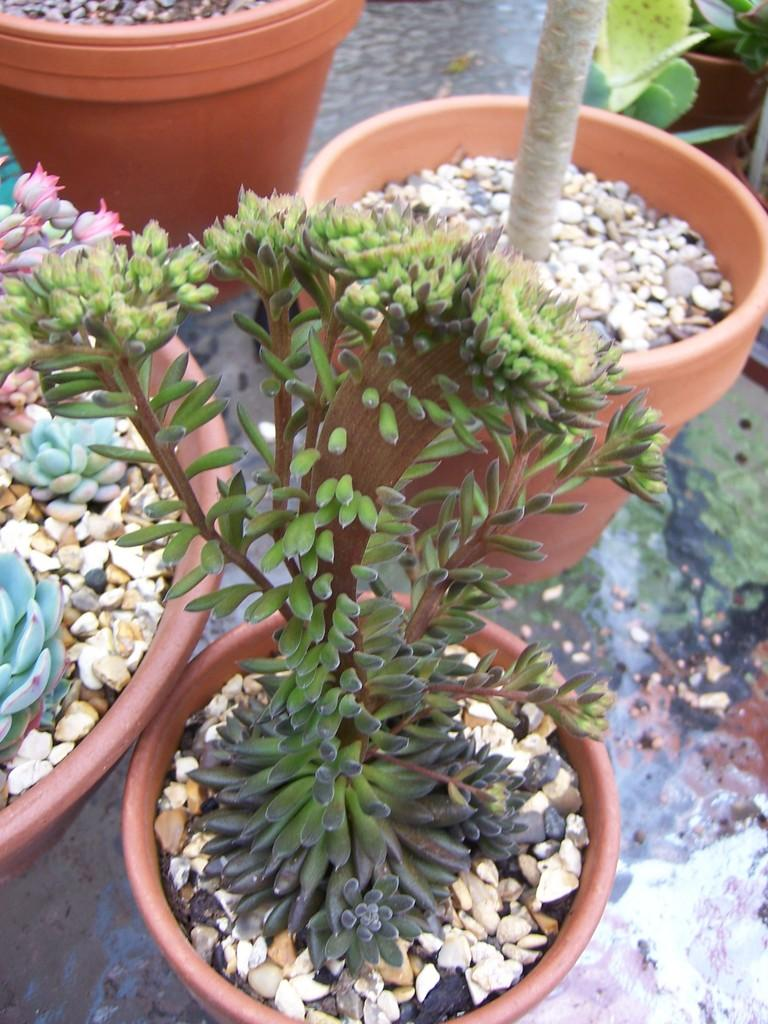What is in the pots in the image? There are plants in the pots. What else can be seen in the pots besides the plants? There are small stones in the pots. What type of honey is being used to water the plants in the image? There is no honey present in the image; the plants are watered with water, not honey. 